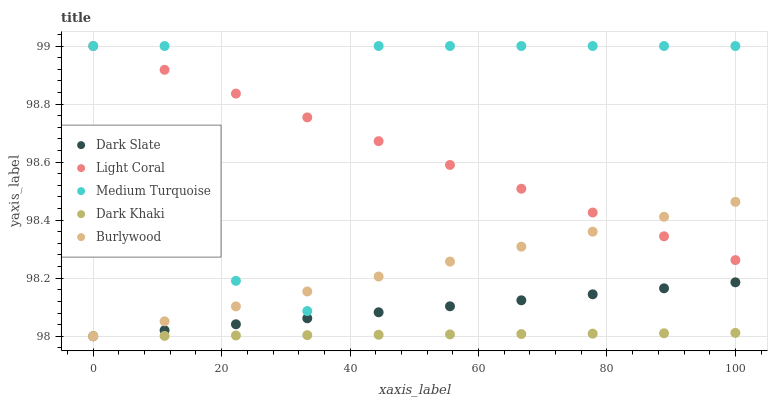Does Dark Khaki have the minimum area under the curve?
Answer yes or no. Yes. Does Medium Turquoise have the maximum area under the curve?
Answer yes or no. Yes. Does Dark Slate have the minimum area under the curve?
Answer yes or no. No. Does Dark Slate have the maximum area under the curve?
Answer yes or no. No. Is Burlywood the smoothest?
Answer yes or no. Yes. Is Medium Turquoise the roughest?
Answer yes or no. Yes. Is Dark Slate the smoothest?
Answer yes or no. No. Is Dark Slate the roughest?
Answer yes or no. No. Does Dark Slate have the lowest value?
Answer yes or no. Yes. Does Medium Turquoise have the lowest value?
Answer yes or no. No. Does Medium Turquoise have the highest value?
Answer yes or no. Yes. Does Dark Slate have the highest value?
Answer yes or no. No. Is Dark Slate less than Light Coral?
Answer yes or no. Yes. Is Light Coral greater than Dark Khaki?
Answer yes or no. Yes. Does Light Coral intersect Burlywood?
Answer yes or no. Yes. Is Light Coral less than Burlywood?
Answer yes or no. No. Is Light Coral greater than Burlywood?
Answer yes or no. No. Does Dark Slate intersect Light Coral?
Answer yes or no. No. 